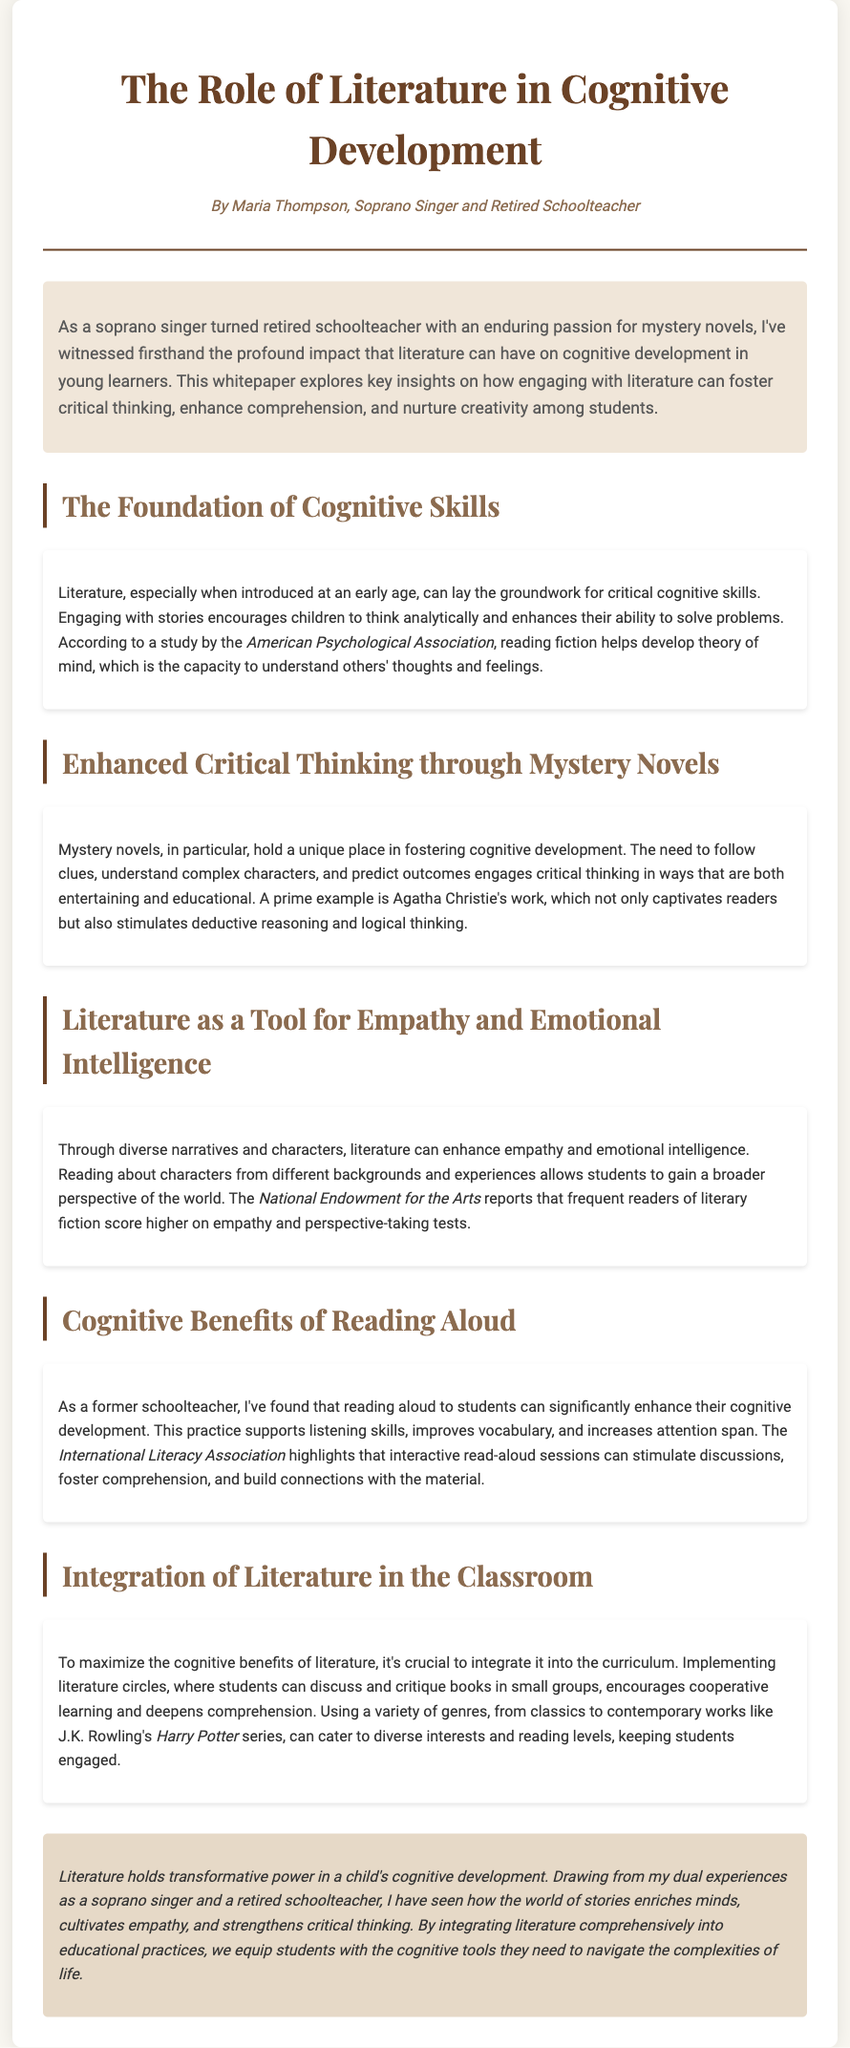What is the title of the whitepaper? The title of the whitepaper is stated at the top of the document.
Answer: The Role of Literature in Cognitive Development Who is the author of the document? The author is mentioned in the header section of the whitepaper.
Answer: Maria Thompson What type of novels does the author emphasize for enhancing critical thinking? The document specifically mentions a type of literature that engages critical thinking.
Answer: Mystery novels What does the American Psychological Association study suggest about reading fiction? The document references a study related to cognitive development and reading fiction.
Answer: Develop theory of mind Which organization highlights the benefits of interactive read-aloud sessions? This information is sourced from a recognized association in the document.
Answer: International Literacy Association What aspect of development does literature enhance according to the National Endowment for the Arts? The document links literature to an important skill in emotional understanding.
Answer: Empathy How does the author recommend integrating literature in the classroom? The document suggests a specific method to facilitate literature engagement among students.
Answer: Literature circles What literary work is mentioned as a contemporary example? The document provides an example of a well-known modern literary series.
Answer: Harry Potter 